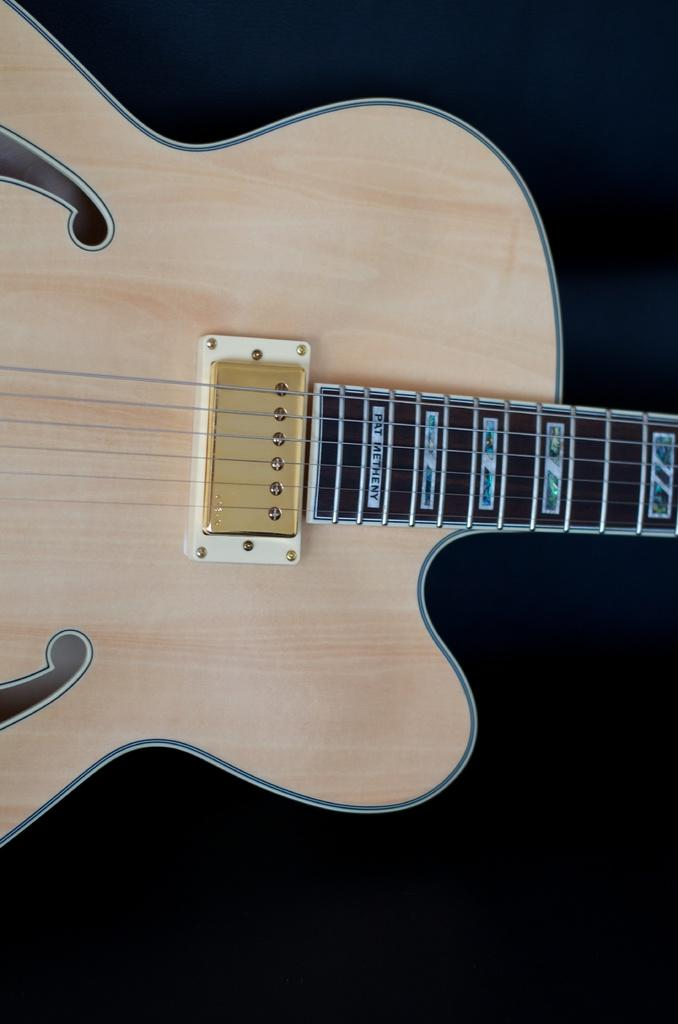What musical instrument is present in the image? There is a guitar in the image. What material is the guitar made of? The guitar is made up of wood. What color is the background of the image? The background of the image is blue. What type of egg is being used as a prop in the image? There is no egg present in the image. What crime is being committed in the image? There is no crime being committed in the image. 